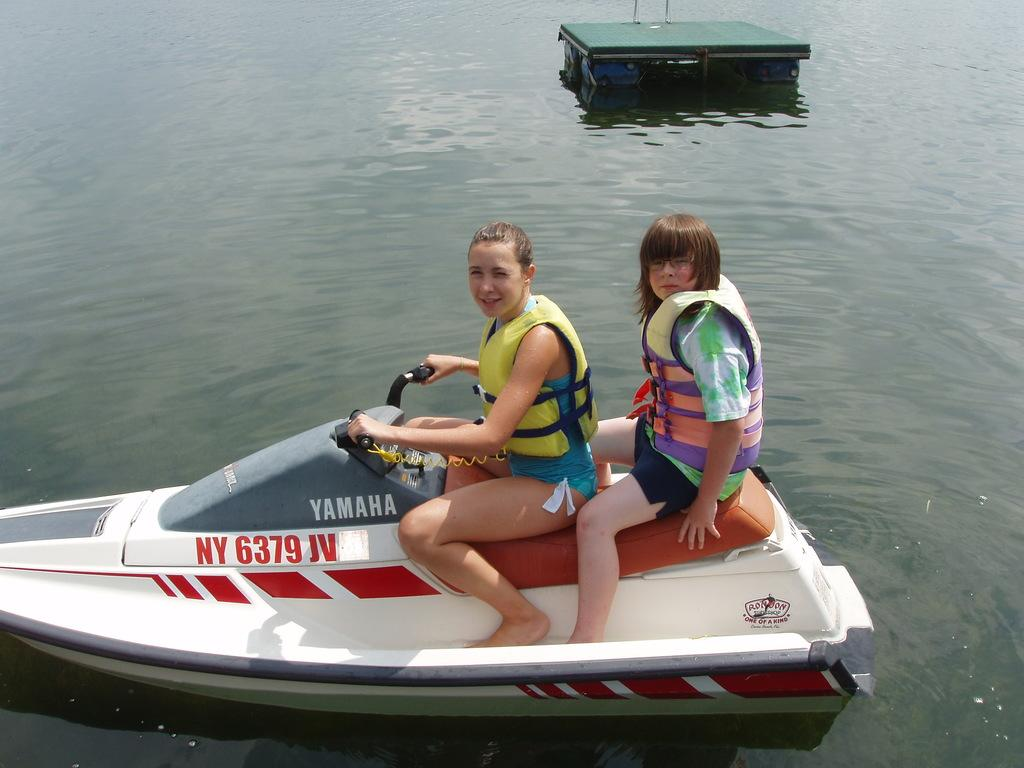How many people are in the image? There are two women in the image. What are the women doing in the image? The women are sitting on a boat. What can be seen in the background of the image? There is water visible in the image. What type of toy is the woman holding in the image? There is no toy visible in the image; the women are sitting on a boat and there are no toys mentioned in the facts. 